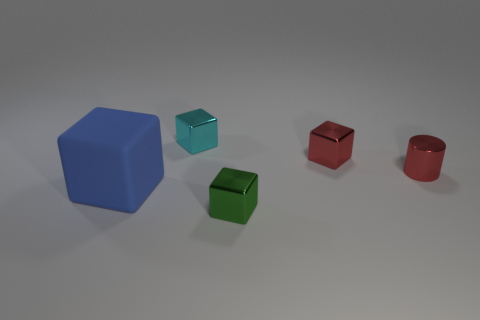Subtract all small red blocks. How many blocks are left? 3 Subtract all green cubes. How many cubes are left? 3 Subtract 1 cylinders. How many cylinders are left? 0 Subtract all cubes. How many objects are left? 1 Add 5 yellow metallic cylinders. How many objects exist? 10 Subtract all yellow cylinders. Subtract all purple blocks. How many cylinders are left? 1 Subtract all big brown metallic things. Subtract all rubber things. How many objects are left? 4 Add 2 small red objects. How many small red objects are left? 4 Add 1 large gray rubber things. How many large gray rubber things exist? 1 Subtract 0 purple spheres. How many objects are left? 5 